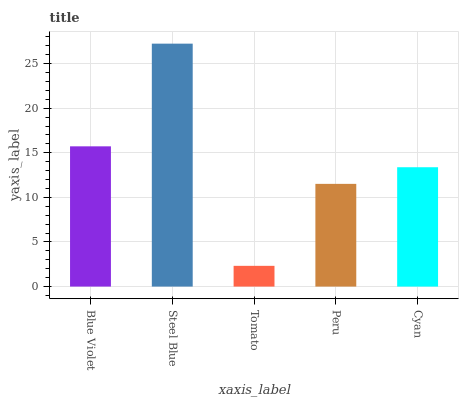Is Steel Blue the minimum?
Answer yes or no. No. Is Tomato the maximum?
Answer yes or no. No. Is Steel Blue greater than Tomato?
Answer yes or no. Yes. Is Tomato less than Steel Blue?
Answer yes or no. Yes. Is Tomato greater than Steel Blue?
Answer yes or no. No. Is Steel Blue less than Tomato?
Answer yes or no. No. Is Cyan the high median?
Answer yes or no. Yes. Is Cyan the low median?
Answer yes or no. Yes. Is Peru the high median?
Answer yes or no. No. Is Blue Violet the low median?
Answer yes or no. No. 